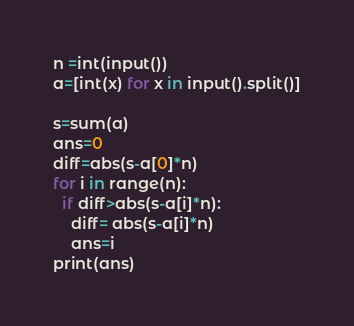<code> <loc_0><loc_0><loc_500><loc_500><_Python_>n =int(input())
a=[int(x) for x in input().split()]
 
s=sum(a)
ans=0
diff=abs(s-a[0]*n)
for i in range(n):
  if diff>abs(s-a[i]*n): 
    diff= abs(s-a[i]*n)
    ans=i
print(ans)</code> 